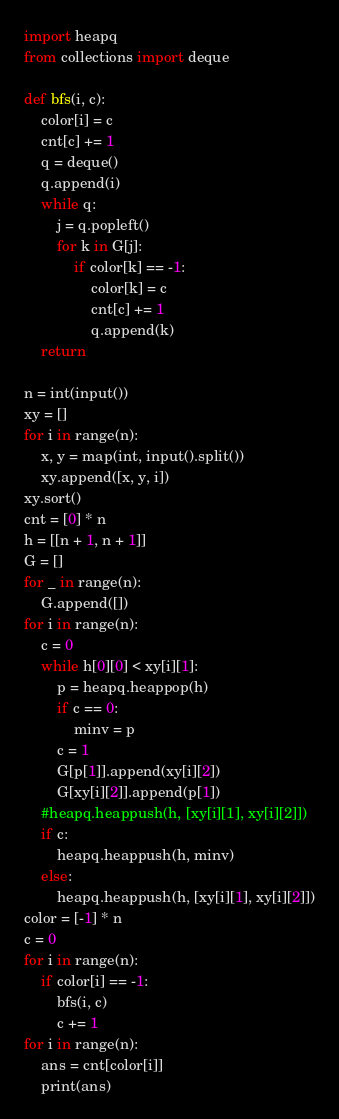<code> <loc_0><loc_0><loc_500><loc_500><_Python_>import heapq
from collections import deque

def bfs(i, c):
    color[i] = c
    cnt[c] += 1
    q = deque()
    q.append(i)
    while q:
        j = q.popleft()
        for k in G[j]:
            if color[k] == -1:
                color[k] = c
                cnt[c] += 1
                q.append(k)
    return

n = int(input())
xy = []
for i in range(n):
    x, y = map(int, input().split())
    xy.append([x, y, i])
xy.sort()
cnt = [0] * n
h = [[n + 1, n + 1]]
G = []
for _ in range(n):
    G.append([])
for i in range(n):
    c = 0
    while h[0][0] < xy[i][1]:
        p = heapq.heappop(h)
        if c == 0:
            minv = p
        c = 1
        G[p[1]].append(xy[i][2])
        G[xy[i][2]].append(p[1])
    #heapq.heappush(h, [xy[i][1], xy[i][2]])
    if c:
        heapq.heappush(h, minv)
    else:
        heapq.heappush(h, [xy[i][1], xy[i][2]])
color = [-1] * n
c = 0
for i in range(n):
    if color[i] == -1:
        bfs(i, c)
        c += 1
for i in range(n):
    ans = cnt[color[i]]
    print(ans)</code> 